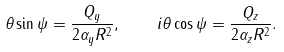Convert formula to latex. <formula><loc_0><loc_0><loc_500><loc_500>\theta \sin \psi = \frac { Q _ { y } } { 2 \alpha _ { y } R ^ { 2 } } , \quad i \theta \cos \psi = \frac { Q _ { z } } { 2 \alpha _ { z } R ^ { 2 } } .</formula> 